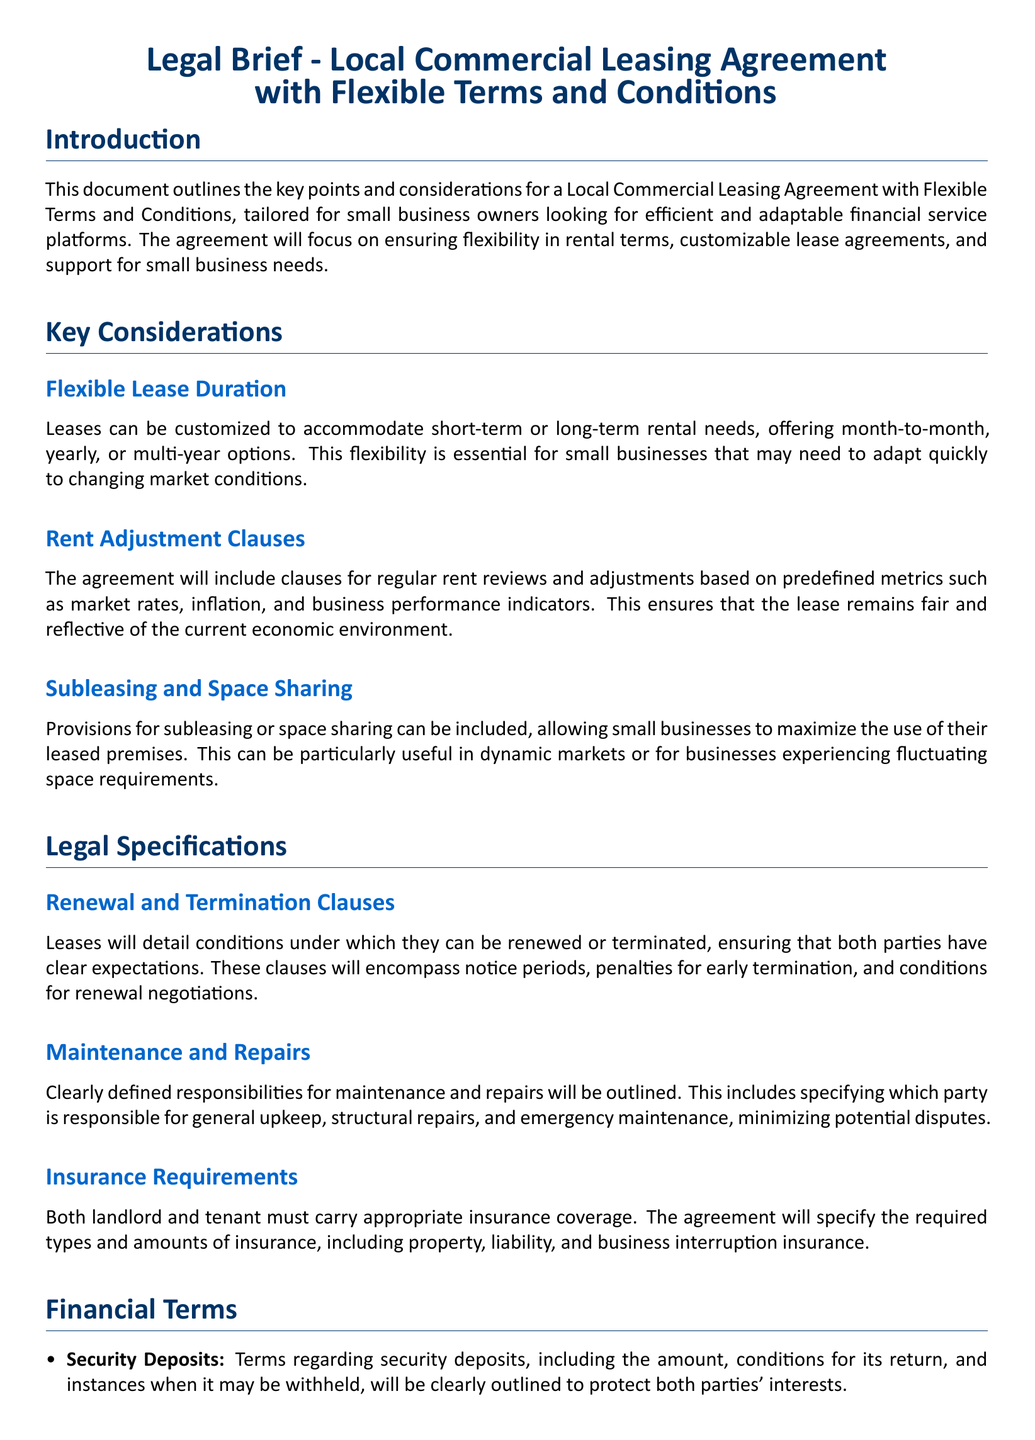What are the lease duration options? The document mentions customizable options for short-term or long-term rental needs, specifically month-to-month, yearly, or multi-year options.
Answer: month-to-month, yearly, multi-year What factors are included in rent adjustment clauses? The agreement includes predefined metrics such as market rates, inflation, and business performance indicators for rent adjustments.
Answer: market rates, inflation, business performance indicators What is specified about maintenance responsibilities? The document outlines clearly defined responsibilities for maintenance and repairs, specifying which party is responsible for general upkeep, structural repairs, and emergency maintenance.
Answer: party responsibilities What types of insurance are required? Both landlord and tenant must carry appropriate insurance coverage, including property, liability, and business interruption insurance.
Answer: property, liability, business interruption What mechanisms are included for dispute resolution? The agreement includes mechanisms such as mediation or arbitration to resolve disputes in a cost-effective and fair manner.
Answer: mediation, arbitration What details are addressed regarding security deposits? Terms regarding security deposits include the amount, conditions for its return, and instances when it may be withheld, protecting both parties' interests.
Answer: amount, conditions for return, instances for withholding What does the agreement state about payment schedules? Flexible payment schedules can be negotiated, allowing tenants to choose from various options based on their financial capabilities and business cycles.
Answer: negotiated flexible schedules What is the purpose of renewal and termination clauses? The clauses detail conditions under which leases can be renewed or terminated, ensuring that both parties have clear expectations regarding notice periods and penalties.
Answer: clear expectations What does the document say about governing law? The agreement specifies the jurisdiction and governing law applicable to the lease, usually based on the location of the property.
Answer: jurisdiction, governing law 